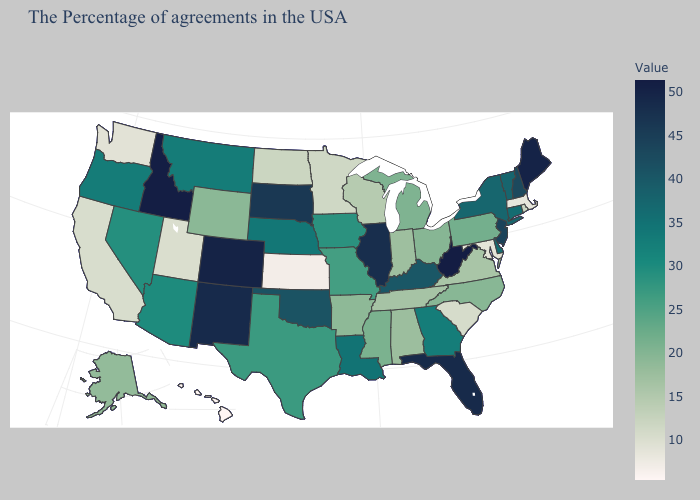Does Nevada have the lowest value in the USA?
Answer briefly. No. Does Idaho have the highest value in the West?
Give a very brief answer. Yes. Among the states that border Alabama , does Florida have the lowest value?
Keep it brief. No. Does Oklahoma have the highest value in the South?
Write a very short answer. No. Among the states that border Rhode Island , which have the lowest value?
Concise answer only. Massachusetts. 